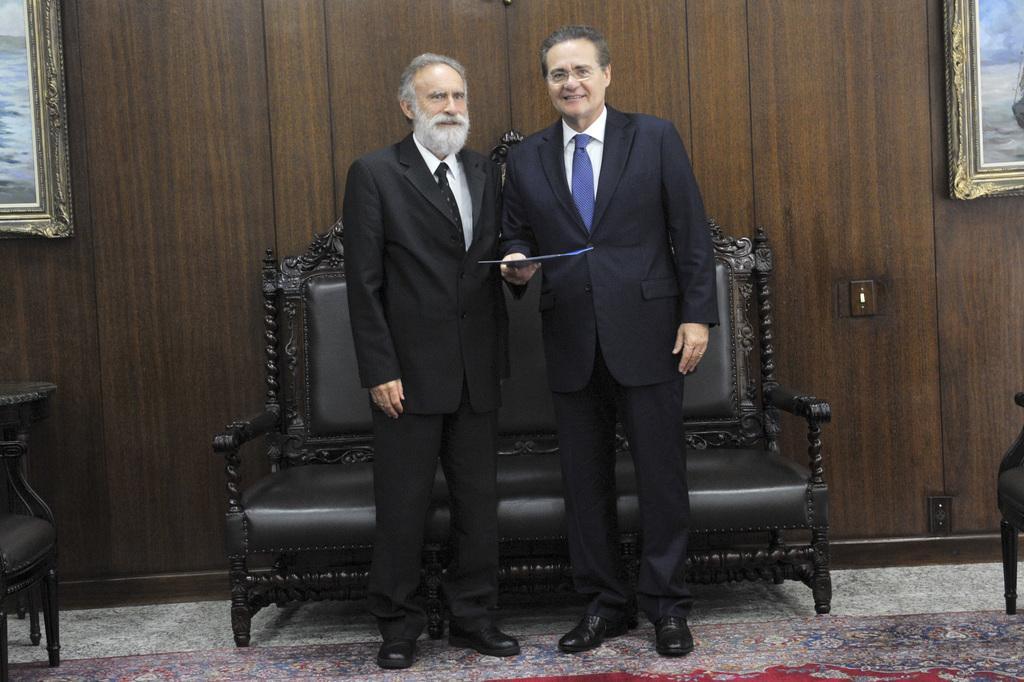Can you describe this image briefly? This the picture of inside of the room. There are two persons standing and at the right and at the left side of the image there are photo frames on the wall. There is a sofa behind this persons. At the bottom there is a mat. 